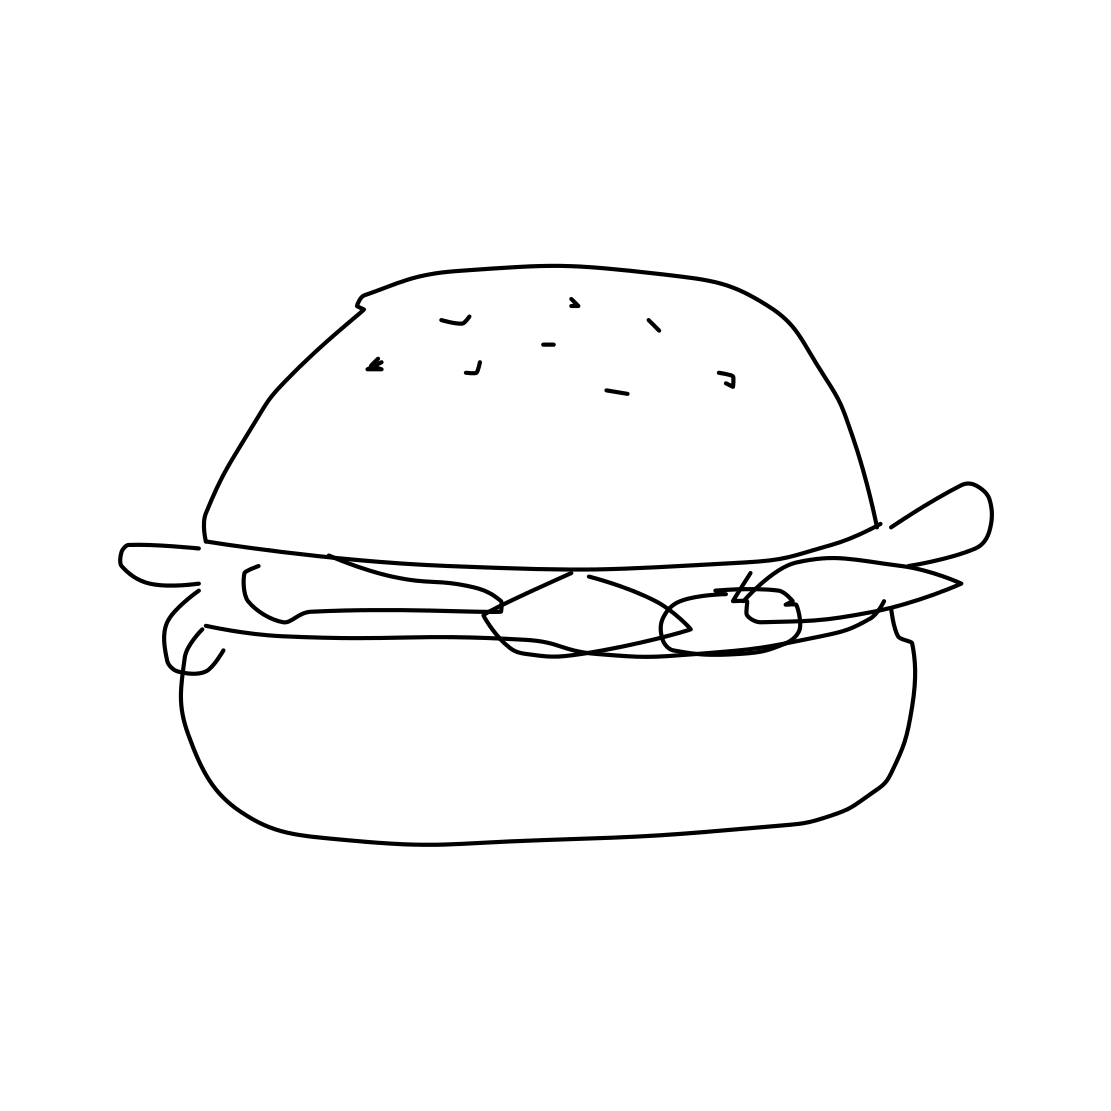Could this image be used effectively in an advertisement for a restaurant? Yes, its clear and simple depiction of a hamburger makes it suitable for use in advertising, particularly if the aim is to convey a sense of classic, uncomplicated deliciousness associated with good, straightforward cooking. What improvements could enhance its appeal in such an ad? Adding color and texture to the drawing could make it more appealing and realistic, potentially attracting more attention. Incorporating some background elements or a logo could also connect the image more directly with a specific brand or dining experience. 